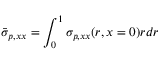<formula> <loc_0><loc_0><loc_500><loc_500>\bar { \sigma } _ { p , x x } = \int _ { 0 } ^ { 1 } \sigma _ { p , x x } ( r , x = 0 ) r d r</formula> 